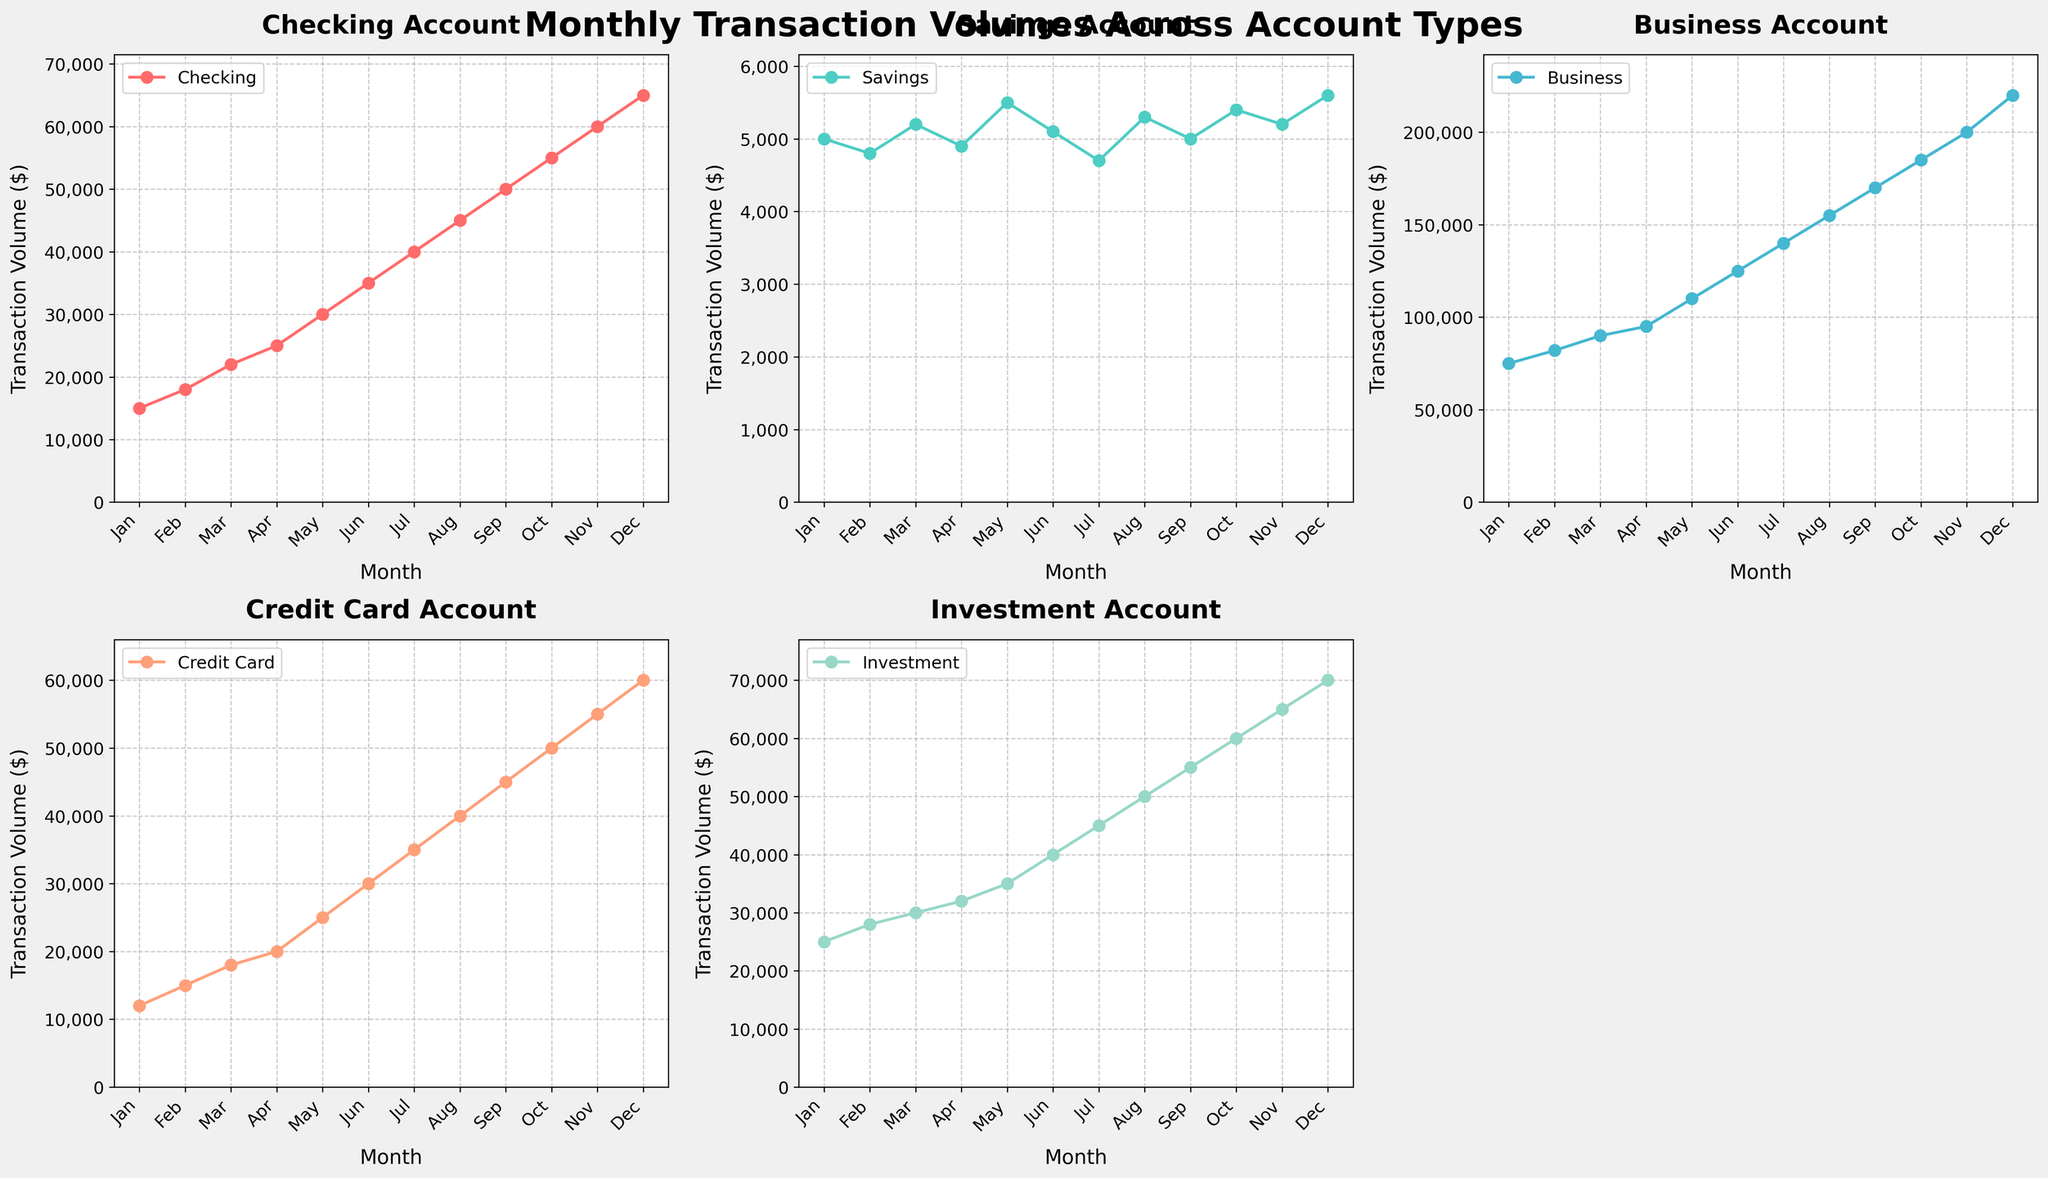What's the title of the figure? The title is located at the top of the figure, usually in a larger and bold font. In this case, it is written as "Monthly Transaction Volumes Across Account Types".
Answer: Monthly Transaction Volumes Across Account Types How many account types are plotted on the figure? You can count the number of subplots in the figure, each labeled with a different account type. There are five subplots, each for Checking, Savings, Business, Credit Card, and Investment accounts.
Answer: 5 Which account type has the highest transaction volume in December? Looking at the December data point on each subplot, the highest transaction volume is for the Business account, reaching 220,000.
Answer: Business What is the trend for the Checking account over the months? Observing the Checking account subplot, the transaction volume increases consistently every month from January (15,000) to December (65,000).
Answer: Upward How much did the transaction volume for the Credit Card account increase from June to July? In the Credit Card account subplot, June's volume is 30,000 and July's volume is 35,000. The difference is 35,000 - 30,000 = 5,000.
Answer: 5,000 What is the average transaction volume for the Savings account over the year? To find the average, sum the monthly values of the Savings account and divide by 12. The sum is (5000 + 4800 + 5200 + 4900 + 5500 + 5100 + 4700 + 5300 + 5000 + 5400 + 5200 + 5600) = 61,000. The average is 61,000 / 12 = 5,083.33.
Answer: 5,083.33 In which month did the Investment account have the lowest transaction volume? The Investment account subplot shows the lowest point in January with a transaction volume of 25,000.
Answer: January Is there any month where the transaction volumes for all account types increased compared to the previous month? By examining each line plot month by month, all account types have increasing volumes from April to May.
Answer: May Compare the transaction volume of the Checking and Investment accounts in October. Which one is greater? In October, the Checking account has a volume of 55,000, whereas the Investment account has a volume of 60,000. The Investment account is greater.
Answer: Investment 